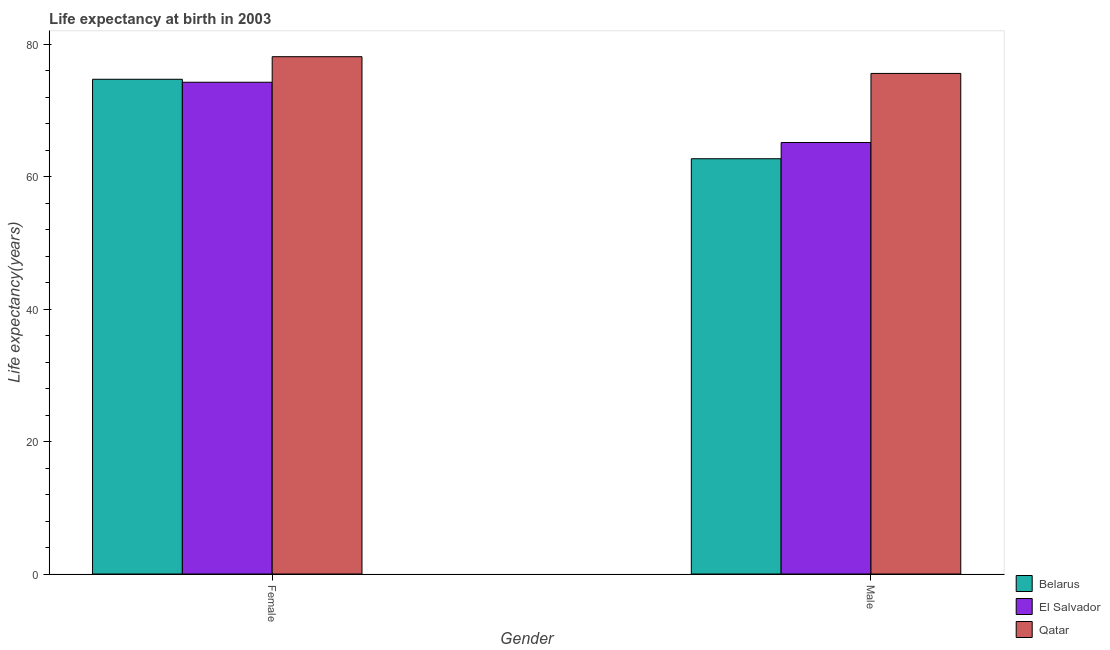How many different coloured bars are there?
Offer a terse response. 3. How many groups of bars are there?
Your response must be concise. 2. Are the number of bars per tick equal to the number of legend labels?
Offer a very short reply. Yes. What is the life expectancy(female) in El Salvador?
Your response must be concise. 74.25. Across all countries, what is the maximum life expectancy(male)?
Ensure brevity in your answer.  75.58. Across all countries, what is the minimum life expectancy(male)?
Keep it short and to the point. 62.7. In which country was the life expectancy(female) maximum?
Ensure brevity in your answer.  Qatar. In which country was the life expectancy(male) minimum?
Offer a terse response. Belarus. What is the total life expectancy(female) in the graph?
Give a very brief answer. 227.06. What is the difference between the life expectancy(female) in Belarus and that in Qatar?
Give a very brief answer. -3.41. What is the difference between the life expectancy(male) in El Salvador and the life expectancy(female) in Belarus?
Offer a terse response. -9.55. What is the average life expectancy(female) per country?
Your response must be concise. 75.69. What is the difference between the life expectancy(male) and life expectancy(female) in El Salvador?
Make the answer very short. -9.1. In how many countries, is the life expectancy(male) greater than 4 years?
Provide a succinct answer. 3. What is the ratio of the life expectancy(female) in Belarus to that in Qatar?
Offer a very short reply. 0.96. In how many countries, is the life expectancy(female) greater than the average life expectancy(female) taken over all countries?
Give a very brief answer. 1. What does the 1st bar from the left in Female represents?
Make the answer very short. Belarus. What does the 3rd bar from the right in Male represents?
Keep it short and to the point. Belarus. Are all the bars in the graph horizontal?
Your response must be concise. No. What is the difference between two consecutive major ticks on the Y-axis?
Your answer should be very brief. 20. Are the values on the major ticks of Y-axis written in scientific E-notation?
Your response must be concise. No. Does the graph contain grids?
Provide a succinct answer. No. What is the title of the graph?
Your answer should be compact. Life expectancy at birth in 2003. Does "Haiti" appear as one of the legend labels in the graph?
Your answer should be very brief. No. What is the label or title of the Y-axis?
Your response must be concise. Life expectancy(years). What is the Life expectancy(years) of Belarus in Female?
Provide a short and direct response. 74.7. What is the Life expectancy(years) of El Salvador in Female?
Offer a terse response. 74.25. What is the Life expectancy(years) of Qatar in Female?
Provide a short and direct response. 78.11. What is the Life expectancy(years) in Belarus in Male?
Ensure brevity in your answer.  62.7. What is the Life expectancy(years) of El Salvador in Male?
Your answer should be very brief. 65.15. What is the Life expectancy(years) in Qatar in Male?
Offer a very short reply. 75.58. Across all Gender, what is the maximum Life expectancy(years) in Belarus?
Give a very brief answer. 74.7. Across all Gender, what is the maximum Life expectancy(years) in El Salvador?
Provide a succinct answer. 74.25. Across all Gender, what is the maximum Life expectancy(years) in Qatar?
Keep it short and to the point. 78.11. Across all Gender, what is the minimum Life expectancy(years) in Belarus?
Make the answer very short. 62.7. Across all Gender, what is the minimum Life expectancy(years) in El Salvador?
Provide a short and direct response. 65.15. Across all Gender, what is the minimum Life expectancy(years) in Qatar?
Make the answer very short. 75.58. What is the total Life expectancy(years) in Belarus in the graph?
Provide a short and direct response. 137.4. What is the total Life expectancy(years) in El Salvador in the graph?
Your answer should be compact. 139.4. What is the total Life expectancy(years) in Qatar in the graph?
Make the answer very short. 153.69. What is the difference between the Life expectancy(years) in El Salvador in Female and that in Male?
Offer a very short reply. 9.1. What is the difference between the Life expectancy(years) in Qatar in Female and that in Male?
Provide a succinct answer. 2.53. What is the difference between the Life expectancy(years) in Belarus in Female and the Life expectancy(years) in El Salvador in Male?
Provide a short and direct response. 9.55. What is the difference between the Life expectancy(years) of Belarus in Female and the Life expectancy(years) of Qatar in Male?
Your answer should be very brief. -0.88. What is the difference between the Life expectancy(years) in El Salvador in Female and the Life expectancy(years) in Qatar in Male?
Provide a succinct answer. -1.33. What is the average Life expectancy(years) of Belarus per Gender?
Your response must be concise. 68.7. What is the average Life expectancy(years) in El Salvador per Gender?
Your answer should be compact. 69.7. What is the average Life expectancy(years) in Qatar per Gender?
Your answer should be compact. 76.85. What is the difference between the Life expectancy(years) in Belarus and Life expectancy(years) in El Salvador in Female?
Ensure brevity in your answer.  0.45. What is the difference between the Life expectancy(years) of Belarus and Life expectancy(years) of Qatar in Female?
Provide a succinct answer. -3.41. What is the difference between the Life expectancy(years) in El Salvador and Life expectancy(years) in Qatar in Female?
Provide a succinct answer. -3.86. What is the difference between the Life expectancy(years) in Belarus and Life expectancy(years) in El Salvador in Male?
Your answer should be very brief. -2.45. What is the difference between the Life expectancy(years) of Belarus and Life expectancy(years) of Qatar in Male?
Keep it short and to the point. -12.88. What is the difference between the Life expectancy(years) of El Salvador and Life expectancy(years) of Qatar in Male?
Your answer should be compact. -10.43. What is the ratio of the Life expectancy(years) of Belarus in Female to that in Male?
Give a very brief answer. 1.19. What is the ratio of the Life expectancy(years) in El Salvador in Female to that in Male?
Your response must be concise. 1.14. What is the ratio of the Life expectancy(years) of Qatar in Female to that in Male?
Ensure brevity in your answer.  1.03. What is the difference between the highest and the second highest Life expectancy(years) of El Salvador?
Your response must be concise. 9.1. What is the difference between the highest and the second highest Life expectancy(years) in Qatar?
Make the answer very short. 2.53. What is the difference between the highest and the lowest Life expectancy(years) of El Salvador?
Your answer should be very brief. 9.1. What is the difference between the highest and the lowest Life expectancy(years) of Qatar?
Make the answer very short. 2.53. 